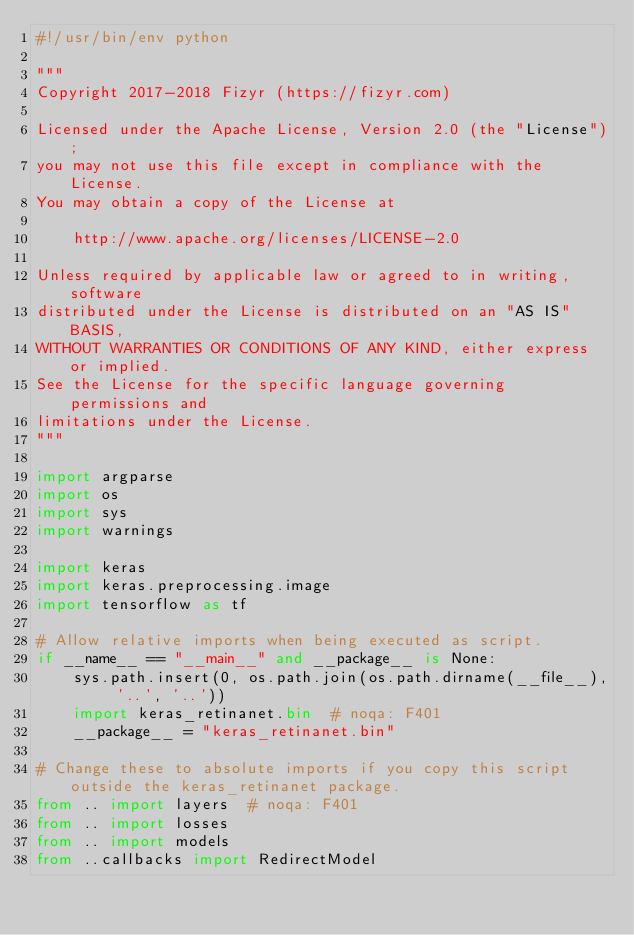Convert code to text. <code><loc_0><loc_0><loc_500><loc_500><_Python_>#!/usr/bin/env python

"""
Copyright 2017-2018 Fizyr (https://fizyr.com)

Licensed under the Apache License, Version 2.0 (the "License");
you may not use this file except in compliance with the License.
You may obtain a copy of the License at

    http://www.apache.org/licenses/LICENSE-2.0

Unless required by applicable law or agreed to in writing, software
distributed under the License is distributed on an "AS IS" BASIS,
WITHOUT WARRANTIES OR CONDITIONS OF ANY KIND, either express or implied.
See the License for the specific language governing permissions and
limitations under the License.
"""

import argparse
import os
import sys
import warnings

import keras
import keras.preprocessing.image
import tensorflow as tf

# Allow relative imports when being executed as script.
if __name__ == "__main__" and __package__ is None:
    sys.path.insert(0, os.path.join(os.path.dirname(__file__), '..', '..'))
    import keras_retinanet.bin  # noqa: F401
    __package__ = "keras_retinanet.bin"

# Change these to absolute imports if you copy this script outside the keras_retinanet package.
from .. import layers  # noqa: F401
from .. import losses
from .. import models
from ..callbacks import RedirectModel</code> 